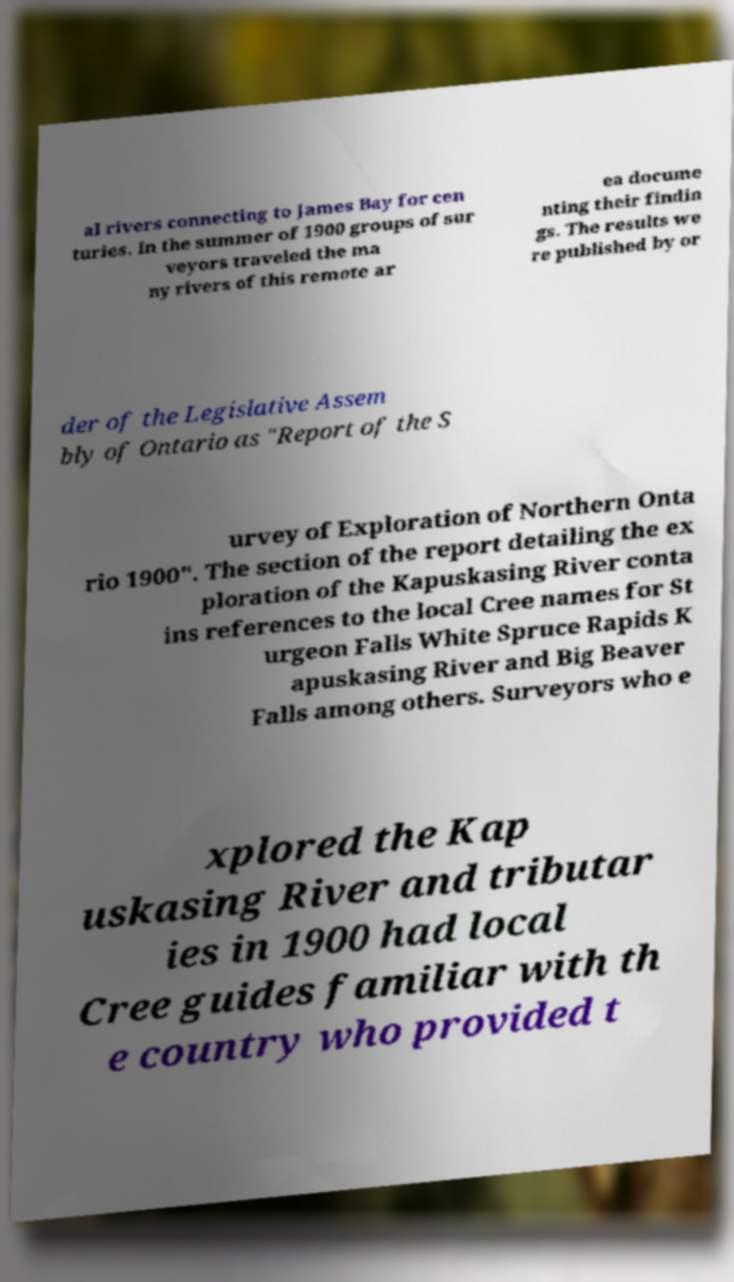Please read and relay the text visible in this image. What does it say? al rivers connecting to James Bay for cen turies. In the summer of 1900 groups of sur veyors traveled the ma ny rivers of this remote ar ea docume nting their findin gs. The results we re published by or der of the Legislative Assem bly of Ontario as "Report of the S urvey of Exploration of Northern Onta rio 1900". The section of the report detailing the ex ploration of the Kapuskasing River conta ins references to the local Cree names for St urgeon Falls White Spruce Rapids K apuskasing River and Big Beaver Falls among others. Surveyors who e xplored the Kap uskasing River and tributar ies in 1900 had local Cree guides familiar with th e country who provided t 